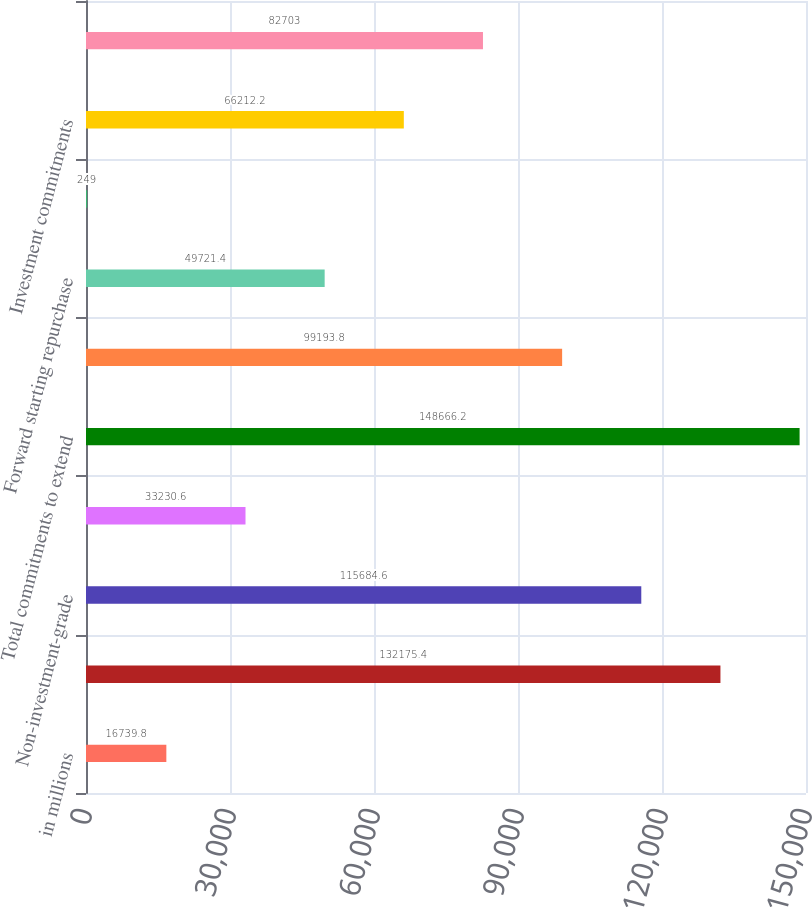<chart> <loc_0><loc_0><loc_500><loc_500><bar_chart><fcel>in millions<fcel>Investment-grade<fcel>Non-investment-grade<fcel>Warehouse financing<fcel>Total commitments to extend<fcel>Contingent and forward<fcel>Forward starting repurchase<fcel>Letters of credit<fcel>Investment commitments<fcel>Other<nl><fcel>16739.8<fcel>132175<fcel>115685<fcel>33230.6<fcel>148666<fcel>99193.8<fcel>49721.4<fcel>249<fcel>66212.2<fcel>82703<nl></chart> 